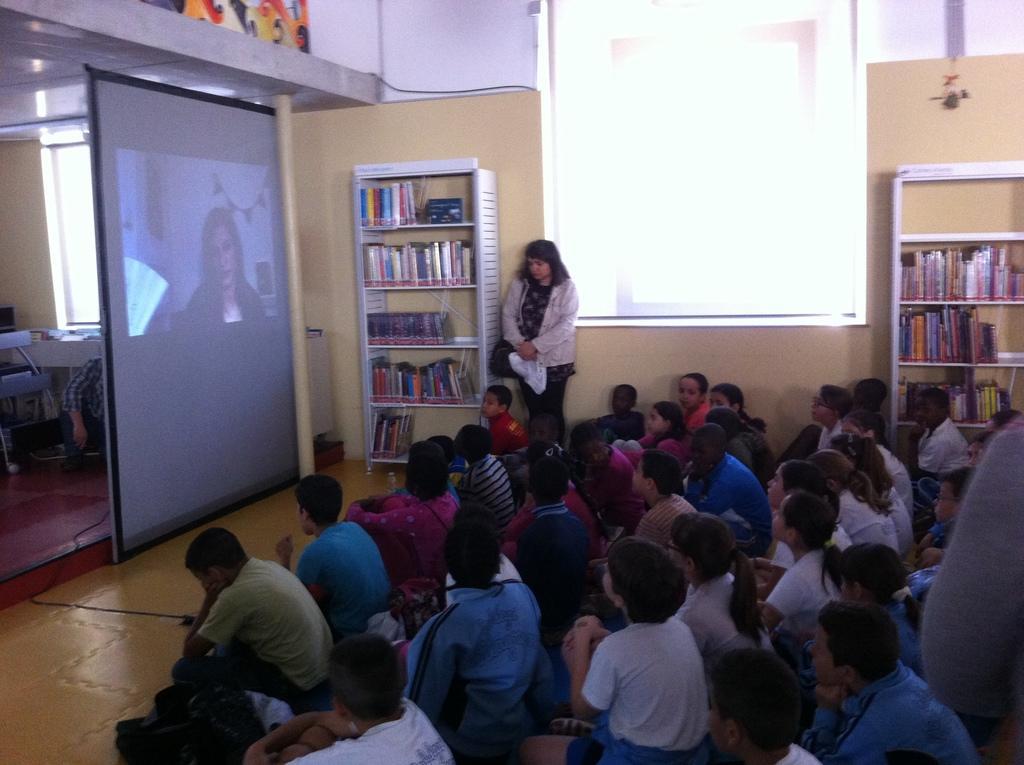Describe this image in one or two sentences. In this image, we can see a few people. There is a projector screen. We can also see the wall. There are some shelves with books in it. We can also see the ground. 